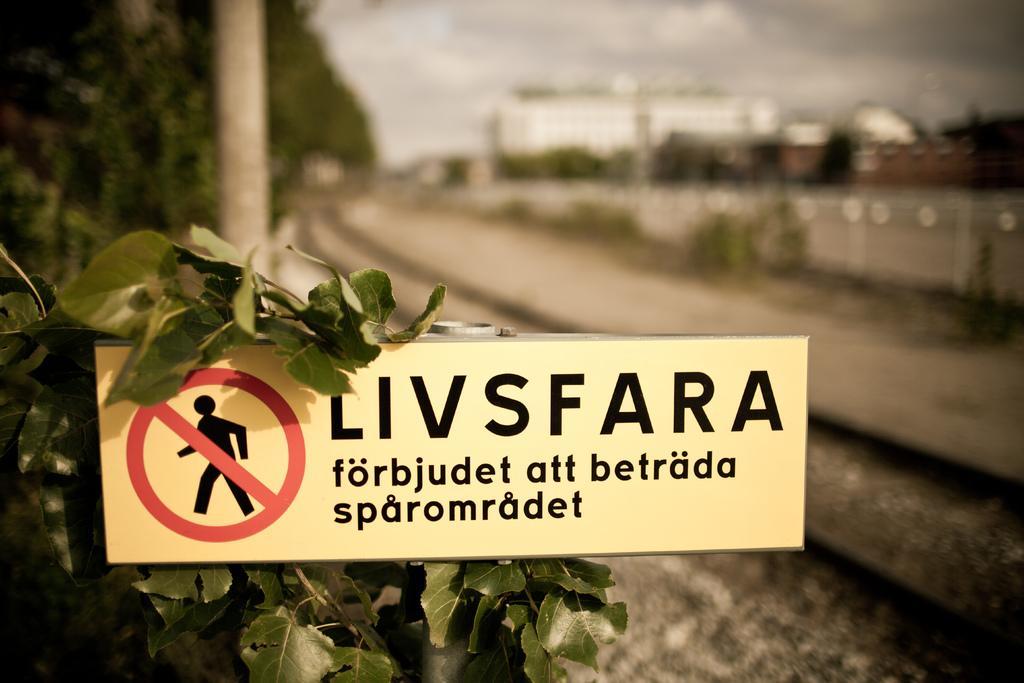Describe this image in one or two sentences. In this image, we can see a board and some leaves. In the background, image is blurred. There is a pole in the top left of the image. There is a track in the middle of the image. There is sky at the top of the image. 